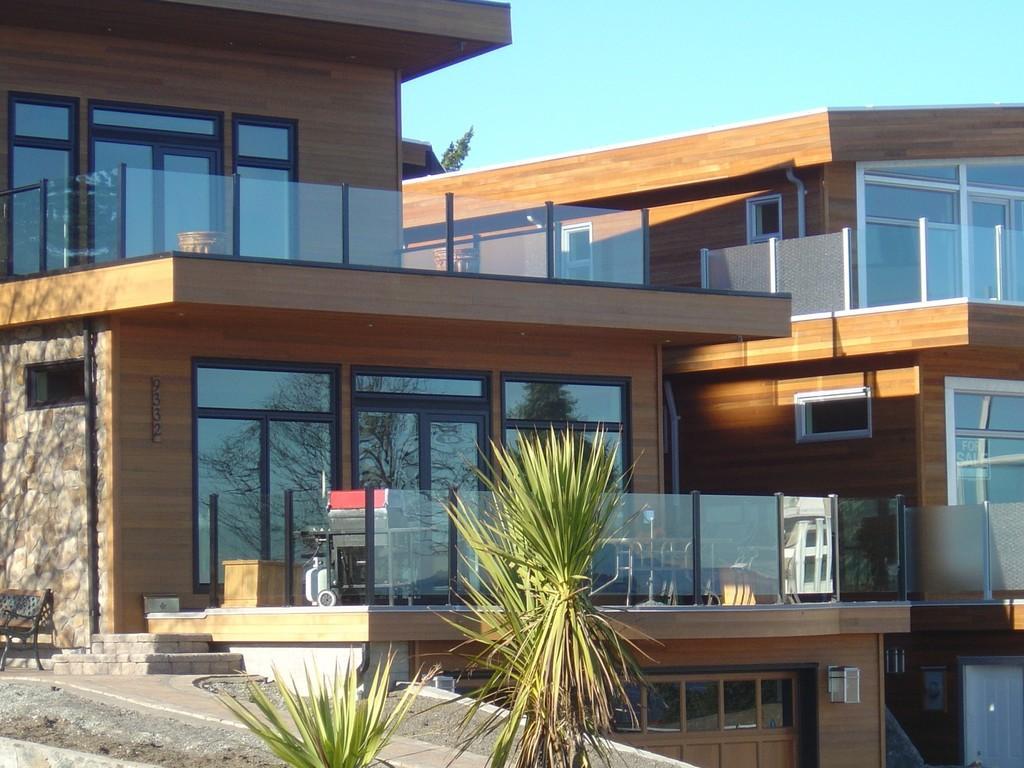Describe this image in one or two sentences. We can see plants, bench and building. In the background we can see green leaves and sky. 